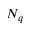Convert formula to latex. <formula><loc_0><loc_0><loc_500><loc_500>N _ { q }</formula> 